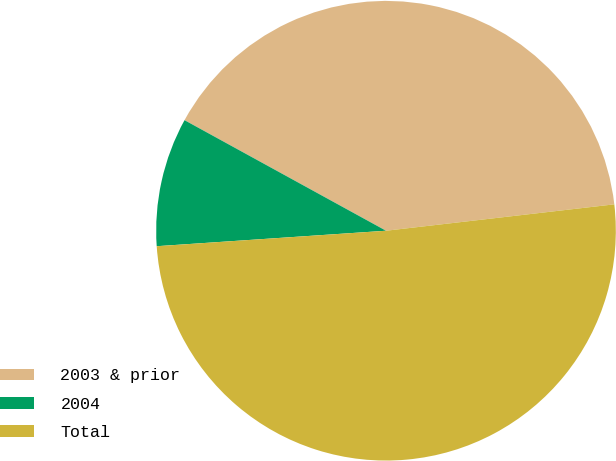<chart> <loc_0><loc_0><loc_500><loc_500><pie_chart><fcel>2003 & prior<fcel>2004<fcel>Total<nl><fcel>40.18%<fcel>9.06%<fcel>50.76%<nl></chart> 